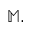<formula> <loc_0><loc_0><loc_500><loc_500>\mathbb { M } .</formula> 